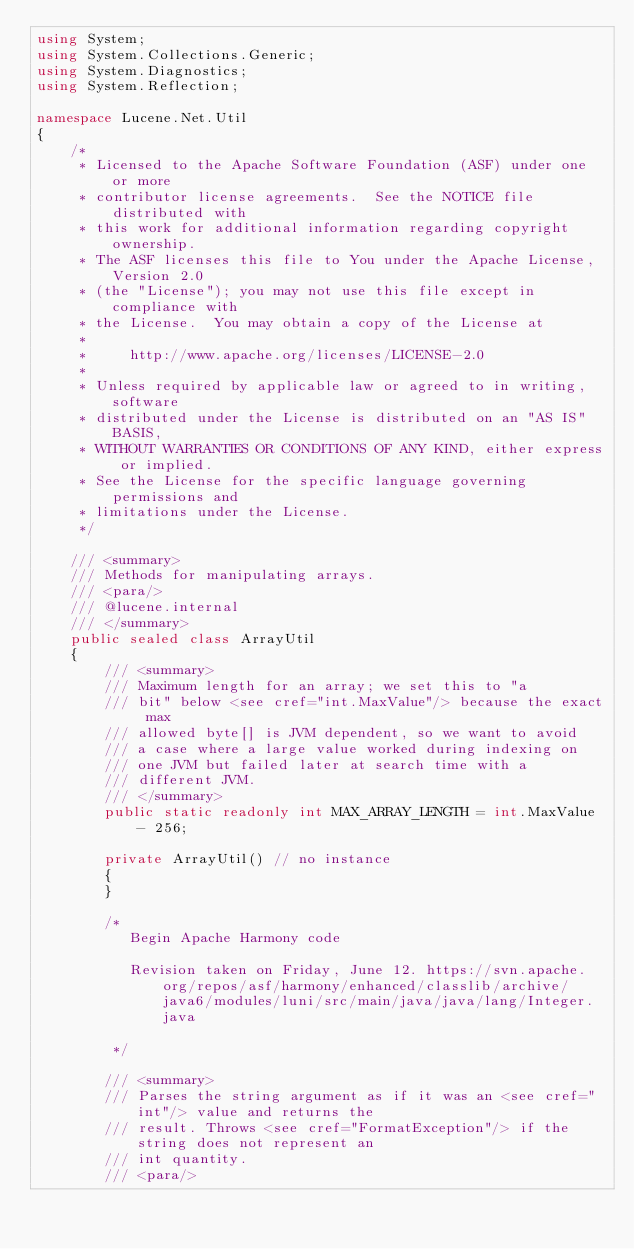<code> <loc_0><loc_0><loc_500><loc_500><_C#_>using System;
using System.Collections.Generic;
using System.Diagnostics;
using System.Reflection;

namespace Lucene.Net.Util
{
    /*
     * Licensed to the Apache Software Foundation (ASF) under one or more
     * contributor license agreements.  See the NOTICE file distributed with
     * this work for additional information regarding copyright ownership.
     * The ASF licenses this file to You under the Apache License, Version 2.0
     * (the "License"); you may not use this file except in compliance with
     * the License.  You may obtain a copy of the License at
     *
     *     http://www.apache.org/licenses/LICENSE-2.0
     *
     * Unless required by applicable law or agreed to in writing, software
     * distributed under the License is distributed on an "AS IS" BASIS,
     * WITHOUT WARRANTIES OR CONDITIONS OF ANY KIND, either express or implied.
     * See the License for the specific language governing permissions and
     * limitations under the License.
     */

    /// <summary>
    /// Methods for manipulating arrays.
    /// <para/>
    /// @lucene.internal
    /// </summary>
    public sealed class ArrayUtil
    {
        /// <summary>
        /// Maximum length for an array; we set this to "a
        /// bit" below <see cref="int.MaxValue"/> because the exact max
        /// allowed byte[] is JVM dependent, so we want to avoid
        /// a case where a large value worked during indexing on
        /// one JVM but failed later at search time with a
        /// different JVM.
        /// </summary>
        public static readonly int MAX_ARRAY_LENGTH = int.MaxValue - 256;

        private ArrayUtil() // no instance
        {
        }

        /*
           Begin Apache Harmony code

           Revision taken on Friday, June 12. https://svn.apache.org/repos/asf/harmony/enhanced/classlib/archive/java6/modules/luni/src/main/java/java/lang/Integer.java

         */

        /// <summary>
        /// Parses the string argument as if it was an <see cref="int"/> value and returns the
        /// result. Throws <see cref="FormatException"/> if the string does not represent an
        /// int quantity.
        /// <para/></code> 